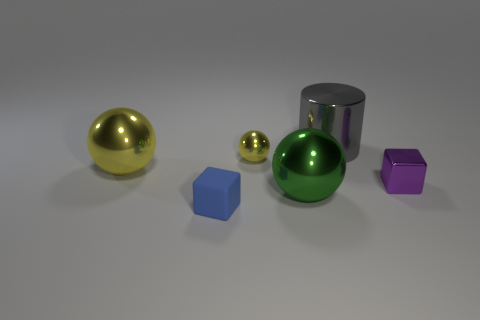Add 2 blue rubber objects. How many objects exist? 8 Subtract all large spheres. How many spheres are left? 1 Subtract all green spheres. How many spheres are left? 2 Subtract all cylinders. How many objects are left? 5 Subtract 2 balls. How many balls are left? 1 Subtract 0 purple cylinders. How many objects are left? 6 Subtract all cyan cylinders. Subtract all cyan cubes. How many cylinders are left? 1 Subtract all cyan balls. How many purple cubes are left? 1 Subtract all large cylinders. Subtract all tiny gray metallic cubes. How many objects are left? 5 Add 5 green shiny objects. How many green shiny objects are left? 6 